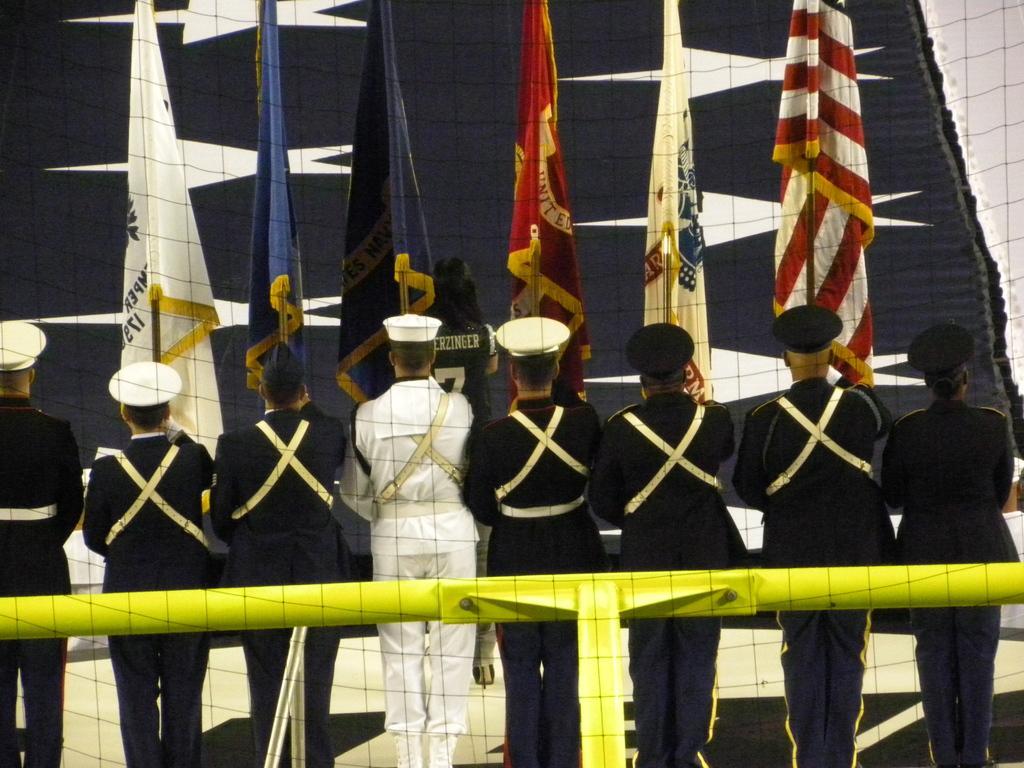Could you give a brief overview of what you see in this image? In this image we see few people standing and holding flags, there is a rod behind the persons and there is an object looks like a flag in the background. 